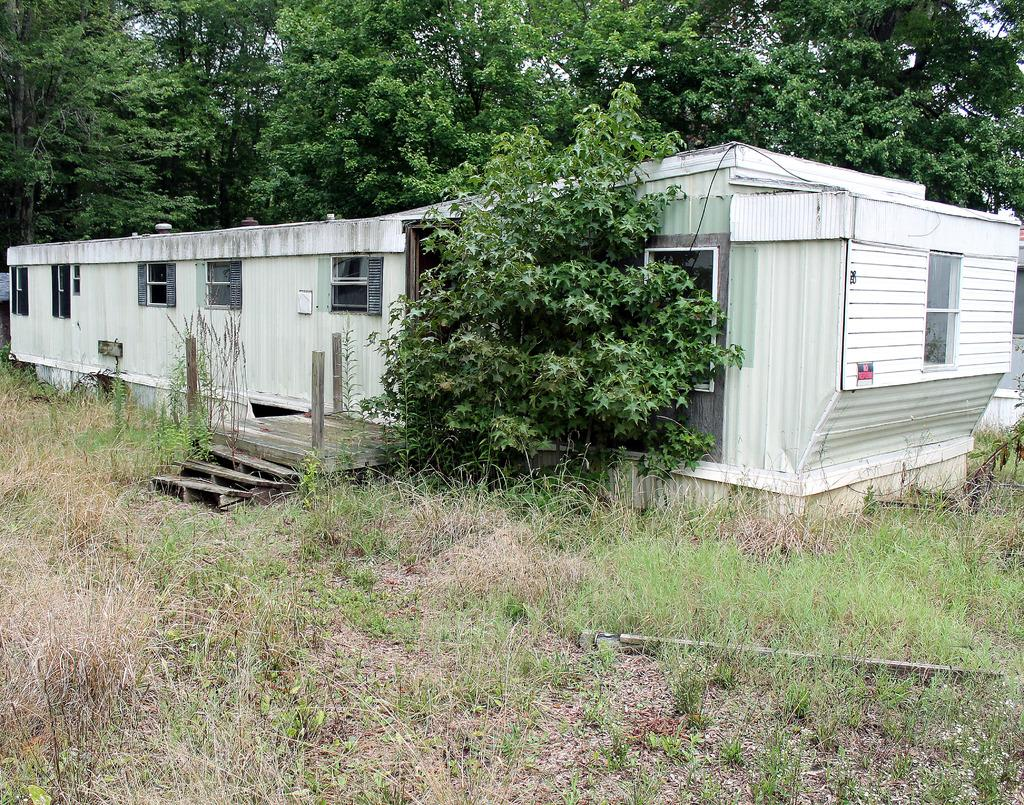What type of structure is present in the image? There is a building in the image. What other natural elements can be seen in the image? There are plants, grassy land, and trees in the image. What is visible behind the trees in the image? The sky is visible behind the trees in the image. Can you see any sand or sea in the image? No, there is no sand or sea present in the image. 